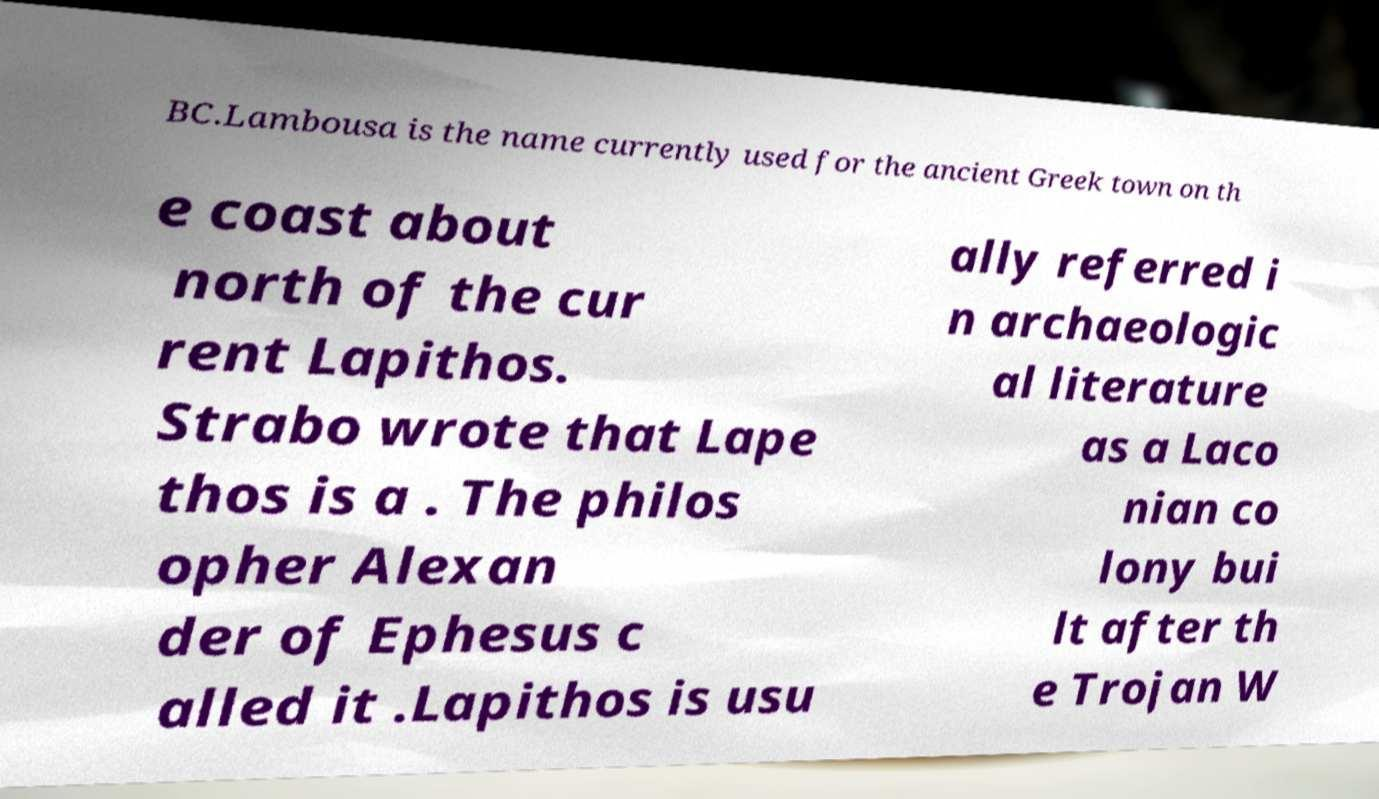Please identify and transcribe the text found in this image. BC.Lambousa is the name currently used for the ancient Greek town on th e coast about north of the cur rent Lapithos. Strabo wrote that Lape thos is a . The philos opher Alexan der of Ephesus c alled it .Lapithos is usu ally referred i n archaeologic al literature as a Laco nian co lony bui lt after th e Trojan W 